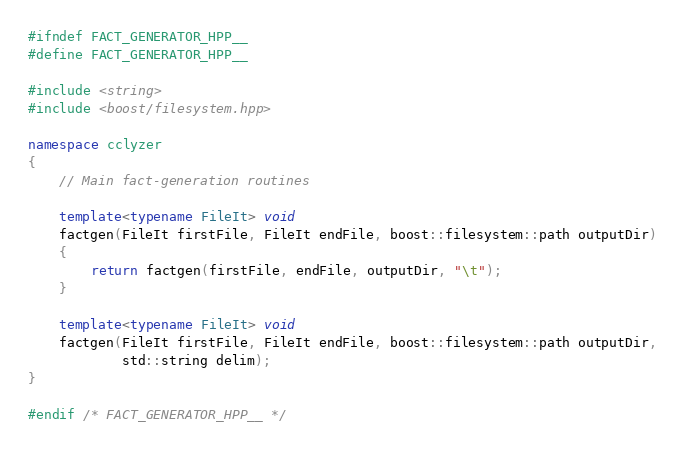Convert code to text. <code><loc_0><loc_0><loc_500><loc_500><_C++_>#ifndef FACT_GENERATOR_HPP__
#define FACT_GENERATOR_HPP__

#include <string>
#include <boost/filesystem.hpp>

namespace cclyzer
{
    // Main fact-generation routines

    template<typename FileIt> void
    factgen(FileIt firstFile, FileIt endFile, boost::filesystem::path outputDir)
    {
        return factgen(firstFile, endFile, outputDir, "\t");
    }

    template<typename FileIt> void
    factgen(FileIt firstFile, FileIt endFile, boost::filesystem::path outputDir,
            std::string delim);
}

#endif /* FACT_GENERATOR_HPP__ */
</code> 